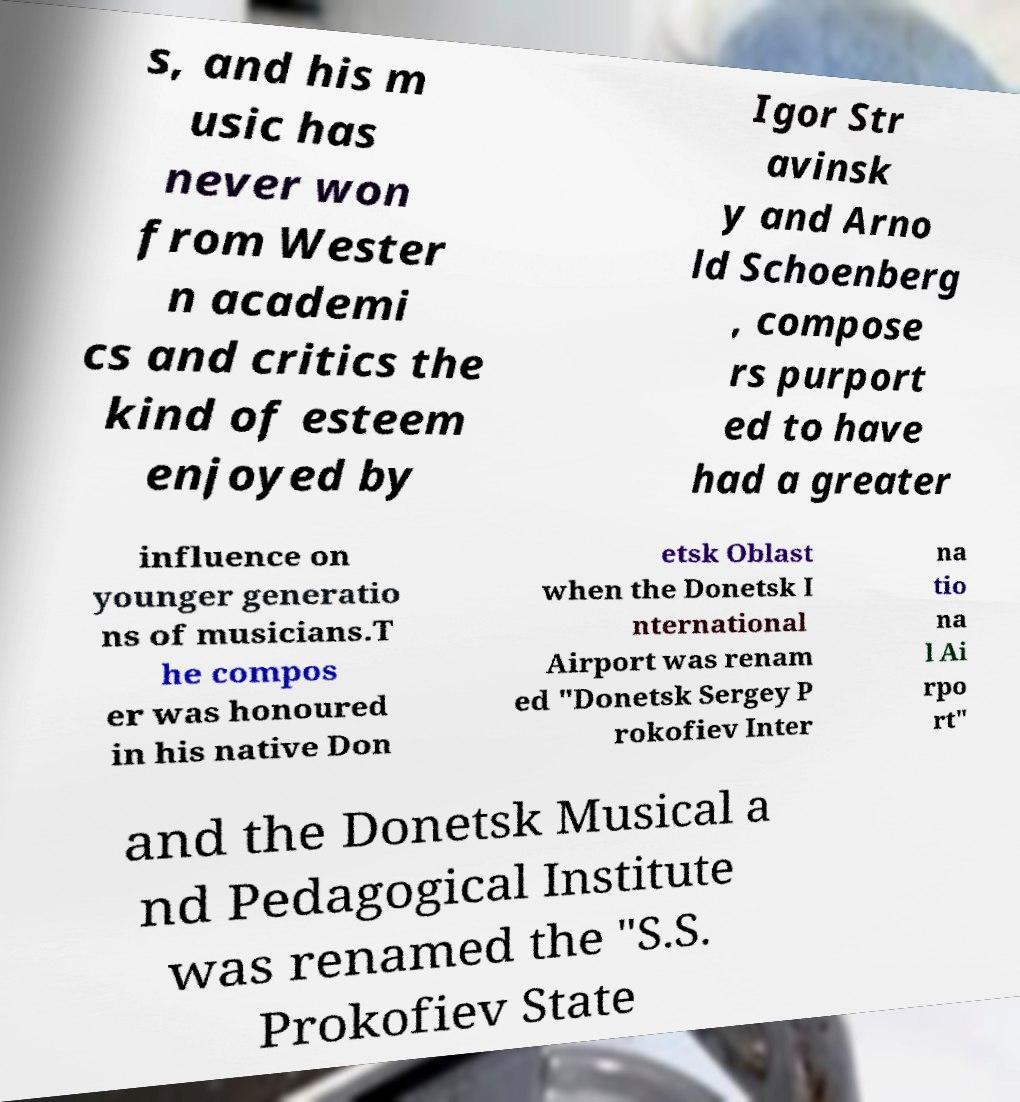For documentation purposes, I need the text within this image transcribed. Could you provide that? s, and his m usic has never won from Wester n academi cs and critics the kind of esteem enjoyed by Igor Str avinsk y and Arno ld Schoenberg , compose rs purport ed to have had a greater influence on younger generatio ns of musicians.T he compos er was honoured in his native Don etsk Oblast when the Donetsk I nternational Airport was renam ed "Donetsk Sergey P rokofiev Inter na tio na l Ai rpo rt" and the Donetsk Musical a nd Pedagogical Institute was renamed the "S.S. Prokofiev State 